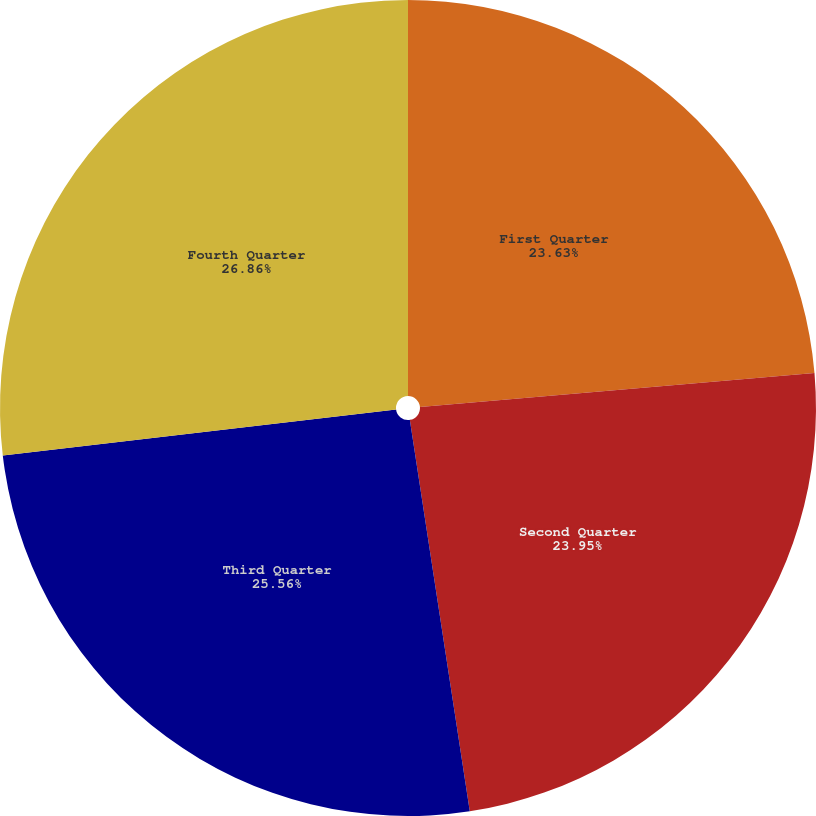<chart> <loc_0><loc_0><loc_500><loc_500><pie_chart><fcel>First Quarter<fcel>Second Quarter<fcel>Third Quarter<fcel>Fourth Quarter<nl><fcel>23.63%<fcel>23.95%<fcel>25.56%<fcel>26.86%<nl></chart> 